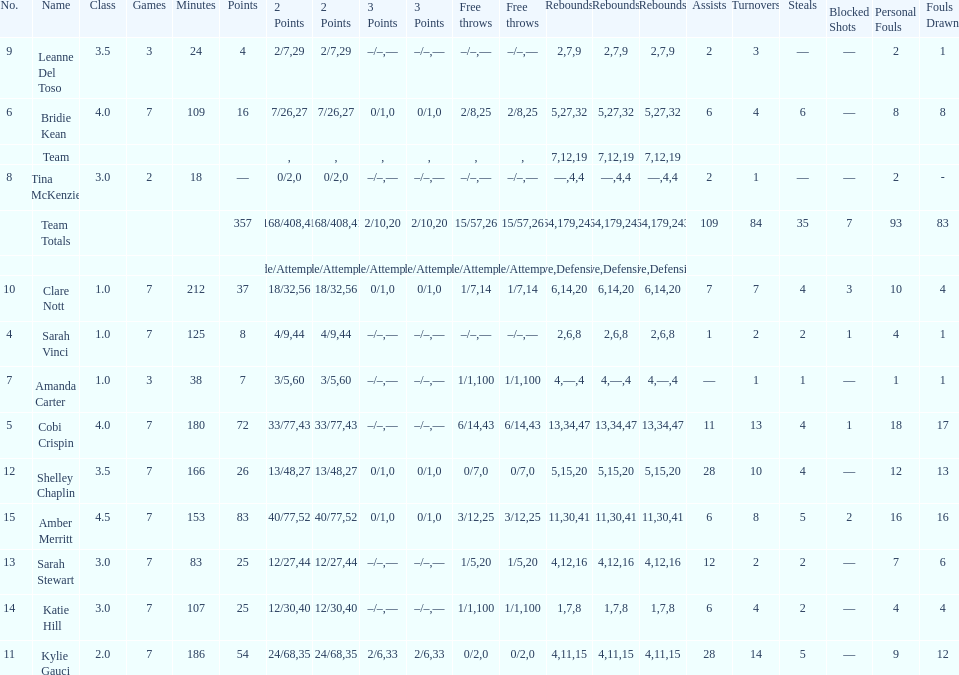Who is the last player on the list to not attempt a 3 point shot? Katie Hill. 